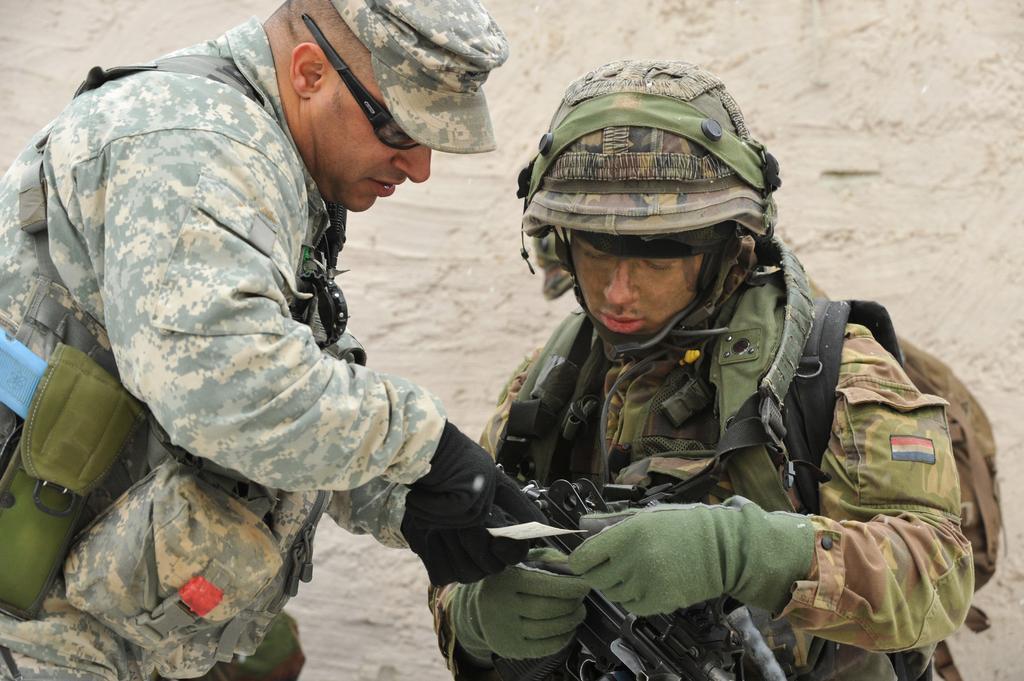How would you summarize this image in a sentence or two? In this picture I can see there are two men standing and they are wearing army uniforms and they are having bags. There are having weapons. The person on to left is wearing a cap and spectacles and there is a another person standing on to right and he is wearing a helmet and there is a wall in the backdrop. 